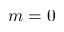<formula> <loc_0><loc_0><loc_500><loc_500>m = 0</formula> 